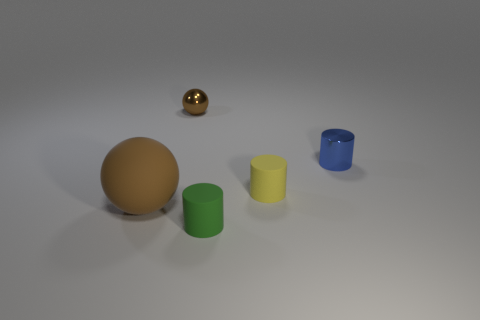Add 3 big rubber blocks. How many objects exist? 8 Subtract all spheres. How many objects are left? 3 Add 3 small yellow matte things. How many small yellow matte things are left? 4 Add 4 yellow rubber blocks. How many yellow rubber blocks exist? 4 Subtract 0 cyan cubes. How many objects are left? 5 Subtract all small blue metal things. Subtract all cylinders. How many objects are left? 1 